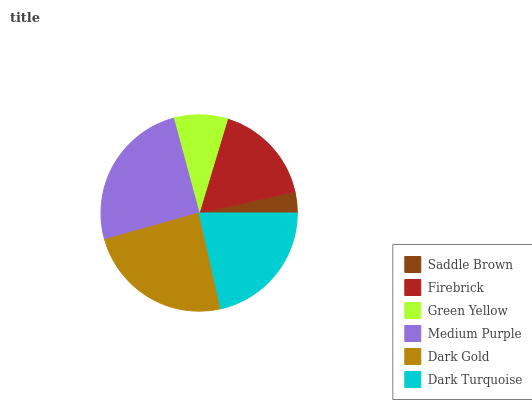Is Saddle Brown the minimum?
Answer yes or no. Yes. Is Medium Purple the maximum?
Answer yes or no. Yes. Is Firebrick the minimum?
Answer yes or no. No. Is Firebrick the maximum?
Answer yes or no. No. Is Firebrick greater than Saddle Brown?
Answer yes or no. Yes. Is Saddle Brown less than Firebrick?
Answer yes or no. Yes. Is Saddle Brown greater than Firebrick?
Answer yes or no. No. Is Firebrick less than Saddle Brown?
Answer yes or no. No. Is Dark Turquoise the high median?
Answer yes or no. Yes. Is Firebrick the low median?
Answer yes or no. Yes. Is Firebrick the high median?
Answer yes or no. No. Is Medium Purple the low median?
Answer yes or no. No. 